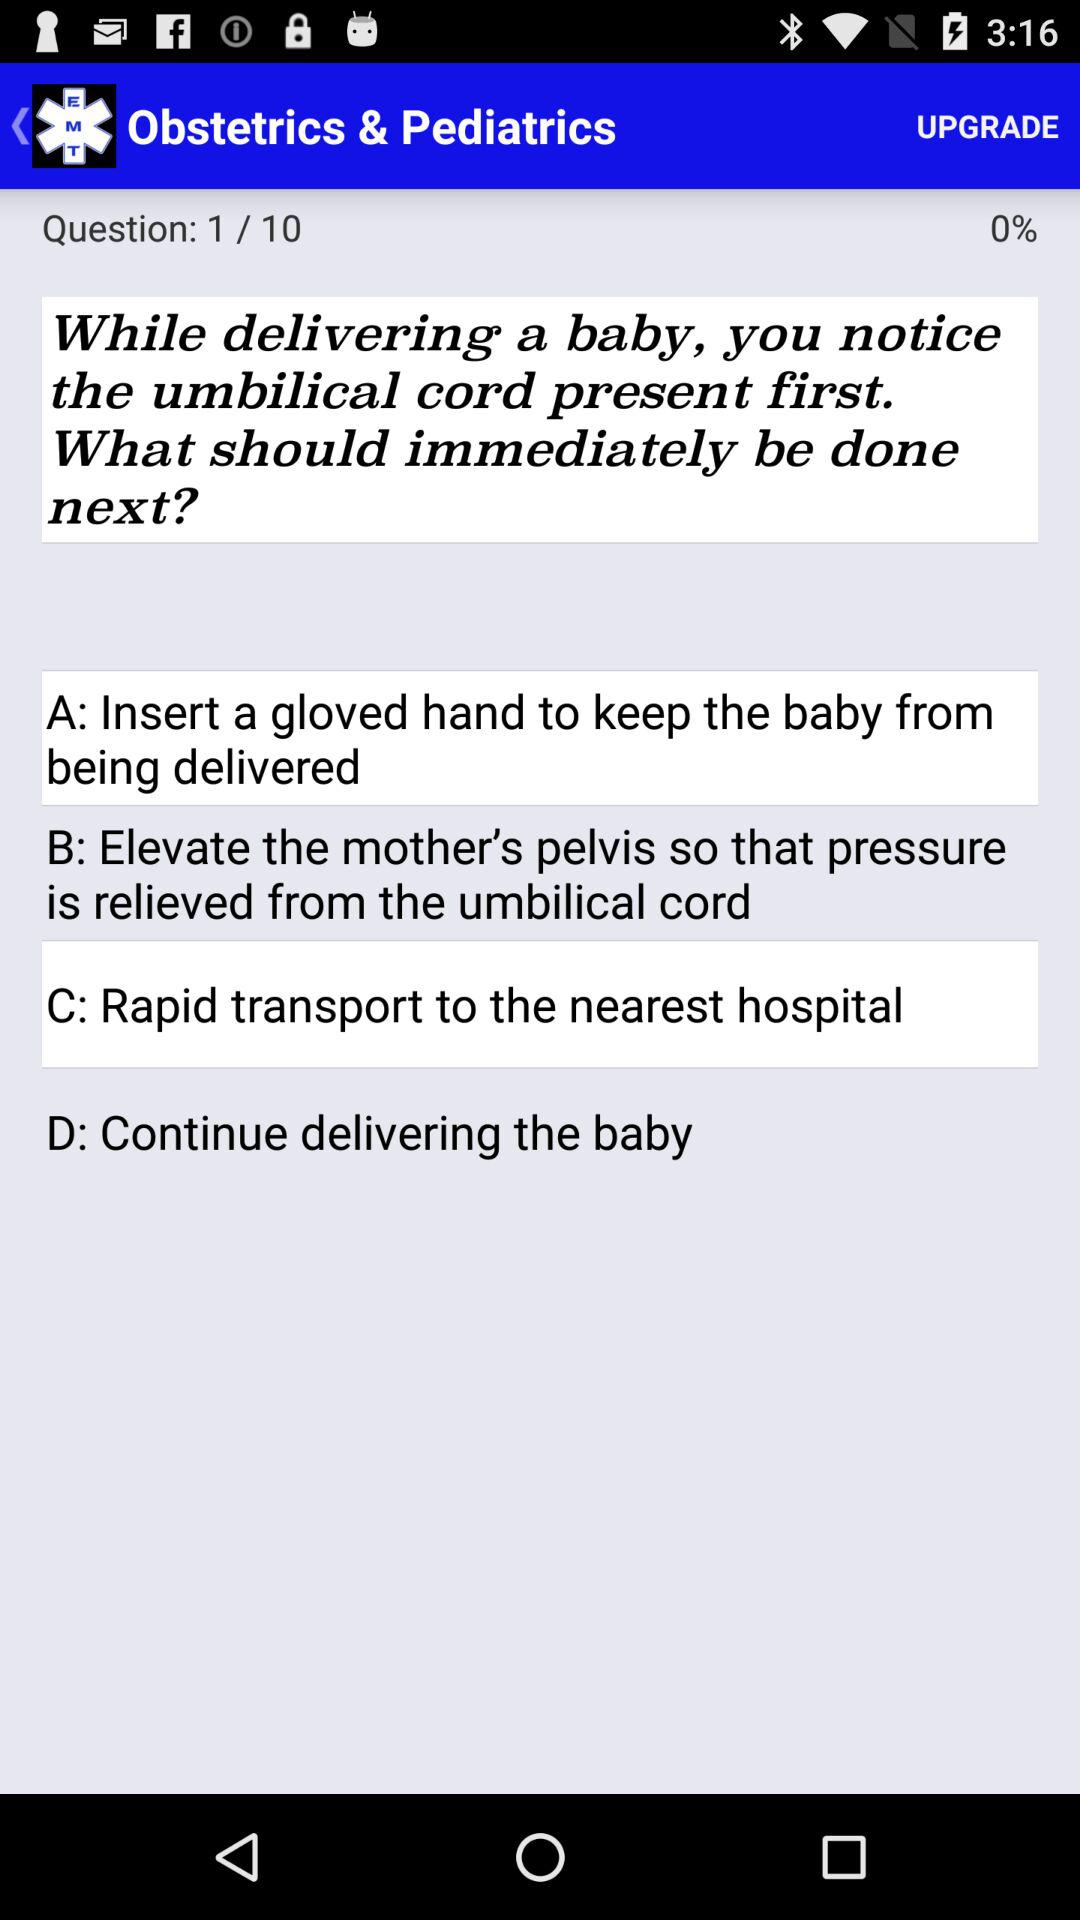What is the current question number? The current question number is 1. 